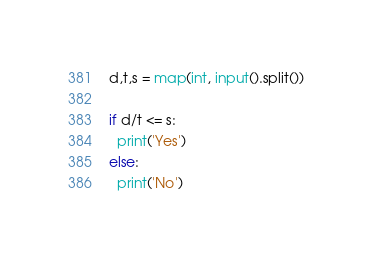<code> <loc_0><loc_0><loc_500><loc_500><_Python_>d,t,s = map(int, input().split())

if d/t <= s:
  print('Yes')
else:
  print('No')</code> 